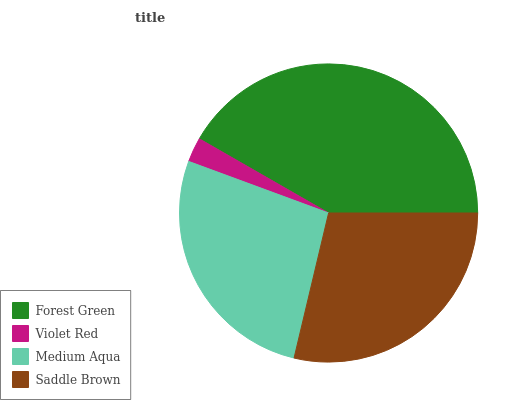Is Violet Red the minimum?
Answer yes or no. Yes. Is Forest Green the maximum?
Answer yes or no. Yes. Is Medium Aqua the minimum?
Answer yes or no. No. Is Medium Aqua the maximum?
Answer yes or no. No. Is Medium Aqua greater than Violet Red?
Answer yes or no. Yes. Is Violet Red less than Medium Aqua?
Answer yes or no. Yes. Is Violet Red greater than Medium Aqua?
Answer yes or no. No. Is Medium Aqua less than Violet Red?
Answer yes or no. No. Is Saddle Brown the high median?
Answer yes or no. Yes. Is Medium Aqua the low median?
Answer yes or no. Yes. Is Forest Green the high median?
Answer yes or no. No. Is Forest Green the low median?
Answer yes or no. No. 